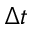<formula> <loc_0><loc_0><loc_500><loc_500>\Delta t</formula> 